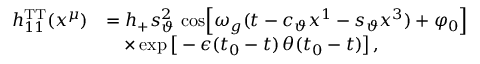Convert formula to latex. <formula><loc_0><loc_0><loc_500><loc_500>\begin{array} { r l } { h _ { 1 1 } ^ { T T } ( x ^ { \mu } ) } & { = h _ { + } s _ { \vartheta } ^ { 2 } \, \cos \, \left [ \omega _ { g } ( t - c _ { \vartheta } x ^ { 1 } - s _ { \vartheta } x ^ { 3 } ) + \varphi _ { 0 } \right ] } \\ & { \quad \times \exp \left [ - \epsilon ( t _ { 0 } - t ) \, \theta ( t _ { 0 } - t ) \right ] \, , } \end{array}</formula> 